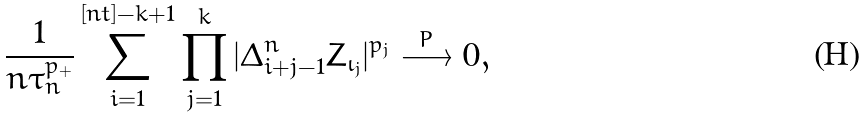Convert formula to latex. <formula><loc_0><loc_0><loc_500><loc_500>\frac { 1 } { n \tau _ { n } ^ { p _ { + } } } \sum _ { i = 1 } ^ { [ n t ] - k + 1 } \prod _ { j = 1 } ^ { k } | \Delta _ { i + j - 1 } ^ { n } Z _ { \iota _ { j } } | ^ { p _ { j } } \stackrel { P } { \longrightarrow } 0 ,</formula> 